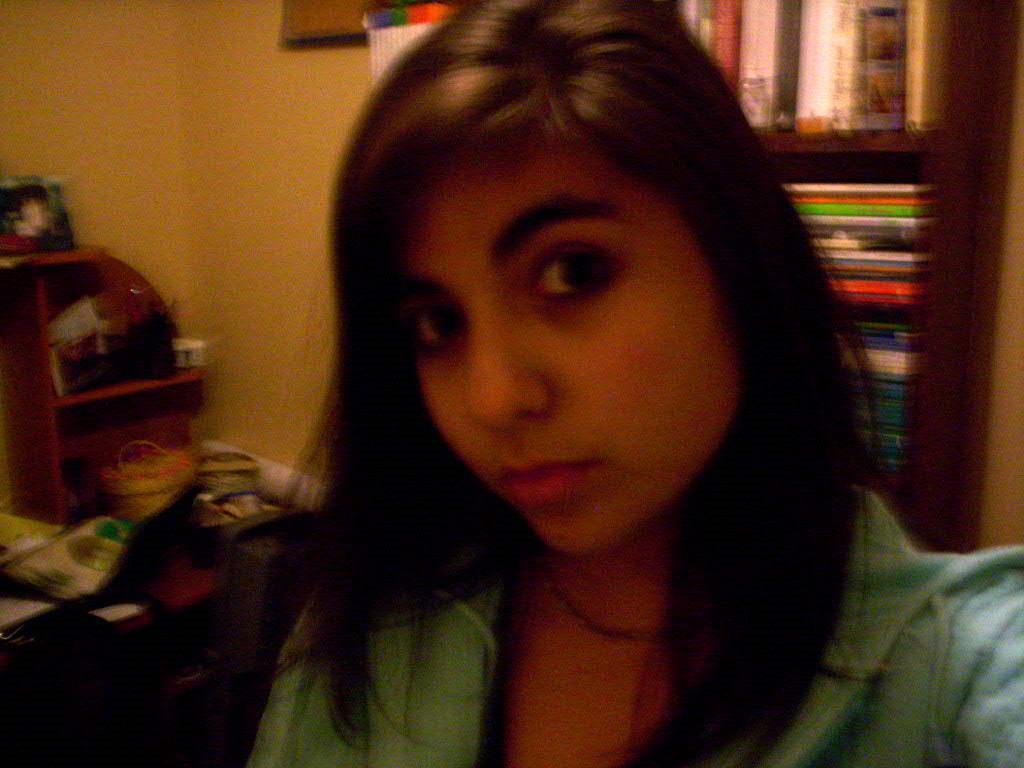In one or two sentences, can you explain what this image depicts? This picture is clicked inside the room. In front of the picture, we see a woman in the blue jacket is posing for the photo. On the left side, we see a chair and a table on which a chart, basket and the objects are placed. Behind that, we see a wall. Behind her, we see a rack in which many books are placed. Beside that, we see a photo frame is placed on the wall. 